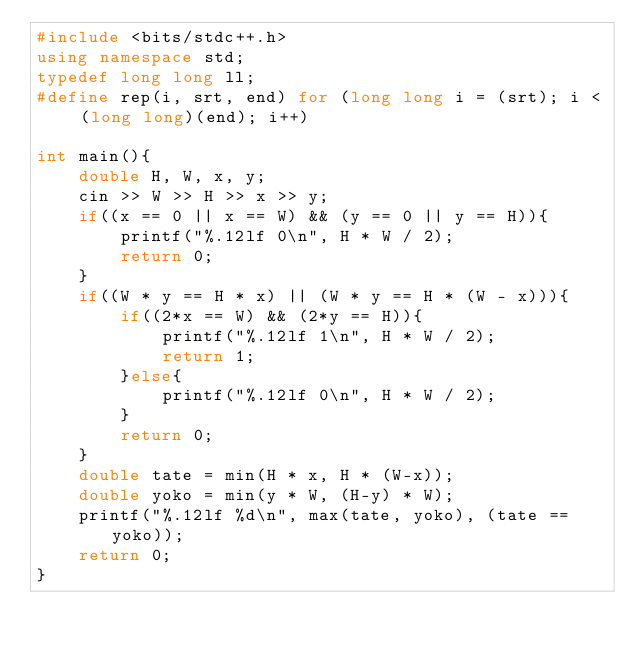Convert code to text. <code><loc_0><loc_0><loc_500><loc_500><_C++_>#include <bits/stdc++.h>
using namespace std;
typedef long long ll;
#define rep(i, srt, end) for (long long i = (srt); i < (long long)(end); i++)

int main(){
    double H, W, x, y;
    cin >> W >> H >> x >> y;
    if((x == 0 || x == W) && (y == 0 || y == H)){
        printf("%.12lf 0\n", H * W / 2);
        return 0;
    }
    if((W * y == H * x) || (W * y == H * (W - x))){
        if((2*x == W) && (2*y == H)){
            printf("%.12lf 1\n", H * W / 2);
            return 1;
        }else{
            printf("%.12lf 0\n", H * W / 2);
        }
        return 0;
    }
    double tate = min(H * x, H * (W-x));
    double yoko = min(y * W, (H-y) * W);
    printf("%.12lf %d\n", max(tate, yoko), (tate == yoko));
    return 0;
}
</code> 